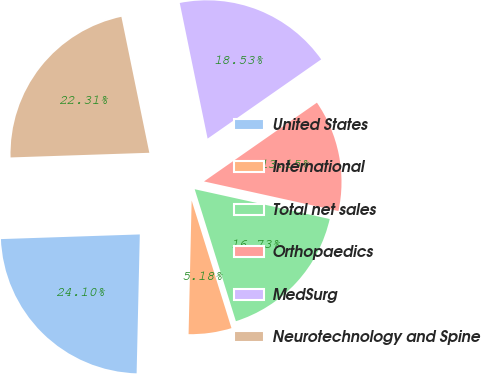Convert chart to OTSL. <chart><loc_0><loc_0><loc_500><loc_500><pie_chart><fcel>United States<fcel>International<fcel>Total net sales<fcel>Orthopaedics<fcel>MedSurg<fcel>Neurotechnology and Spine<nl><fcel>24.1%<fcel>5.18%<fcel>16.73%<fcel>13.15%<fcel>18.53%<fcel>22.31%<nl></chart> 